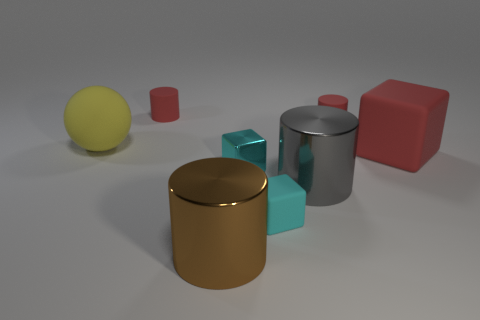Add 2 spheres. How many objects exist? 10 Subtract all spheres. How many objects are left? 7 Subtract all brown objects. Subtract all tiny red things. How many objects are left? 5 Add 7 tiny cyan things. How many tiny cyan things are left? 9 Add 6 small brown things. How many small brown things exist? 6 Subtract 0 yellow blocks. How many objects are left? 8 